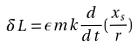<formula> <loc_0><loc_0><loc_500><loc_500>\delta L = \epsilon m k \frac { d } { d t } ( \frac { x _ { s } } { r } )</formula> 